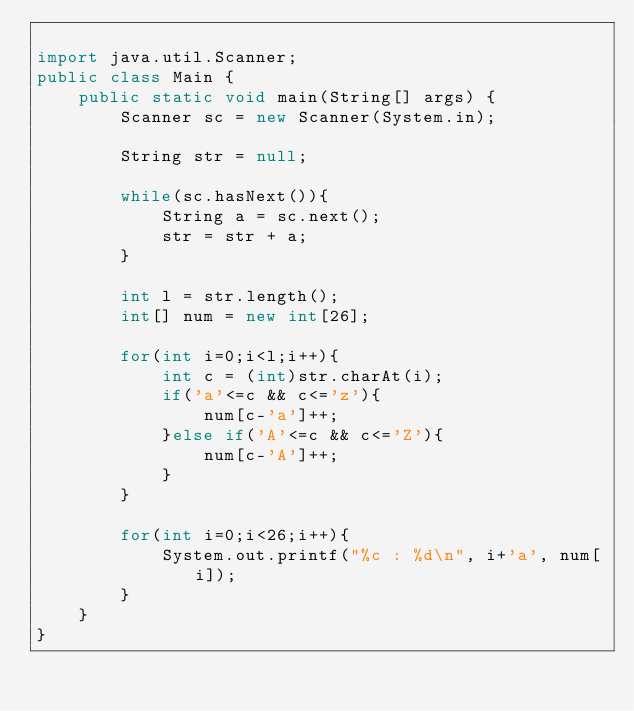Convert code to text. <code><loc_0><loc_0><loc_500><loc_500><_Java_>
import java.util.Scanner;
public class Main {
    public static void main(String[] args) {
        Scanner sc = new Scanner(System.in);

        String str = null;

        while(sc.hasNext()){
            String a = sc.next();
            str = str + a;
        }

        int l = str.length();
        int[] num = new int[26];

        for(int i=0;i<l;i++){
            int c = (int)str.charAt(i);
            if('a'<=c && c<='z'){
                num[c-'a']++;
            }else if('A'<=c && c<='Z'){
                num[c-'A']++;
            }
        }

        for(int i=0;i<26;i++){
            System.out.printf("%c : %d\n", i+'a', num[i]);
        }
    }
}

</code> 